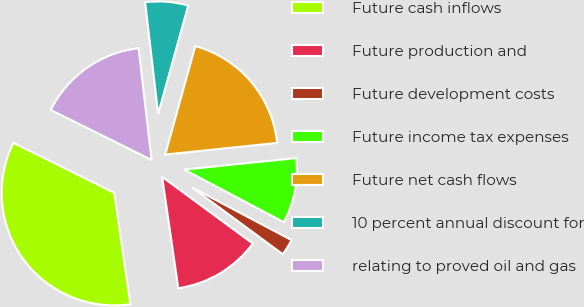<chart> <loc_0><loc_0><loc_500><loc_500><pie_chart><fcel>Future cash inflows<fcel>Future production and<fcel>Future development costs<fcel>Future income tax expenses<fcel>Future net cash flows<fcel>10 percent annual discount for<fcel>relating to proved oil and gas<nl><fcel>34.62%<fcel>12.61%<fcel>2.36%<fcel>9.38%<fcel>19.06%<fcel>6.15%<fcel>15.83%<nl></chart> 